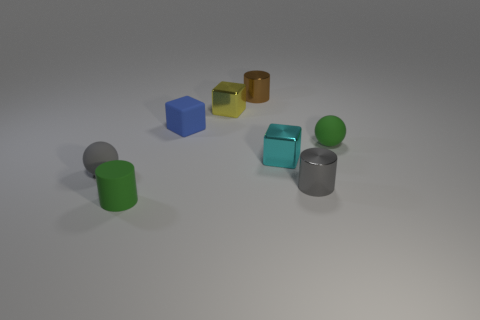Are there an equal number of tiny cyan cubes that are right of the gray shiny thing and small green cylinders to the left of the rubber cylinder?
Provide a short and direct response. Yes. What is the color of the object that is both behind the gray metal cylinder and to the right of the tiny cyan cube?
Ensure brevity in your answer.  Green. What is the material of the small gray thing in front of the tiny gray thing to the left of the green cylinder?
Your answer should be compact. Metal. Do the blue rubber block and the gray cylinder have the same size?
Provide a short and direct response. Yes. What number of tiny objects are either rubber cubes or gray metallic cylinders?
Ensure brevity in your answer.  2. There is a gray shiny cylinder; what number of tiny yellow blocks are behind it?
Provide a short and direct response. 1. Are there more yellow shiny cubes that are in front of the tiny cyan metal object than gray spheres?
Make the answer very short. No. What shape is the brown thing that is the same material as the cyan object?
Offer a very short reply. Cylinder. What color is the metallic cube in front of the tiny green thing on the right side of the small green matte cylinder?
Your response must be concise. Cyan. Do the small cyan object and the blue matte thing have the same shape?
Provide a succinct answer. Yes. 